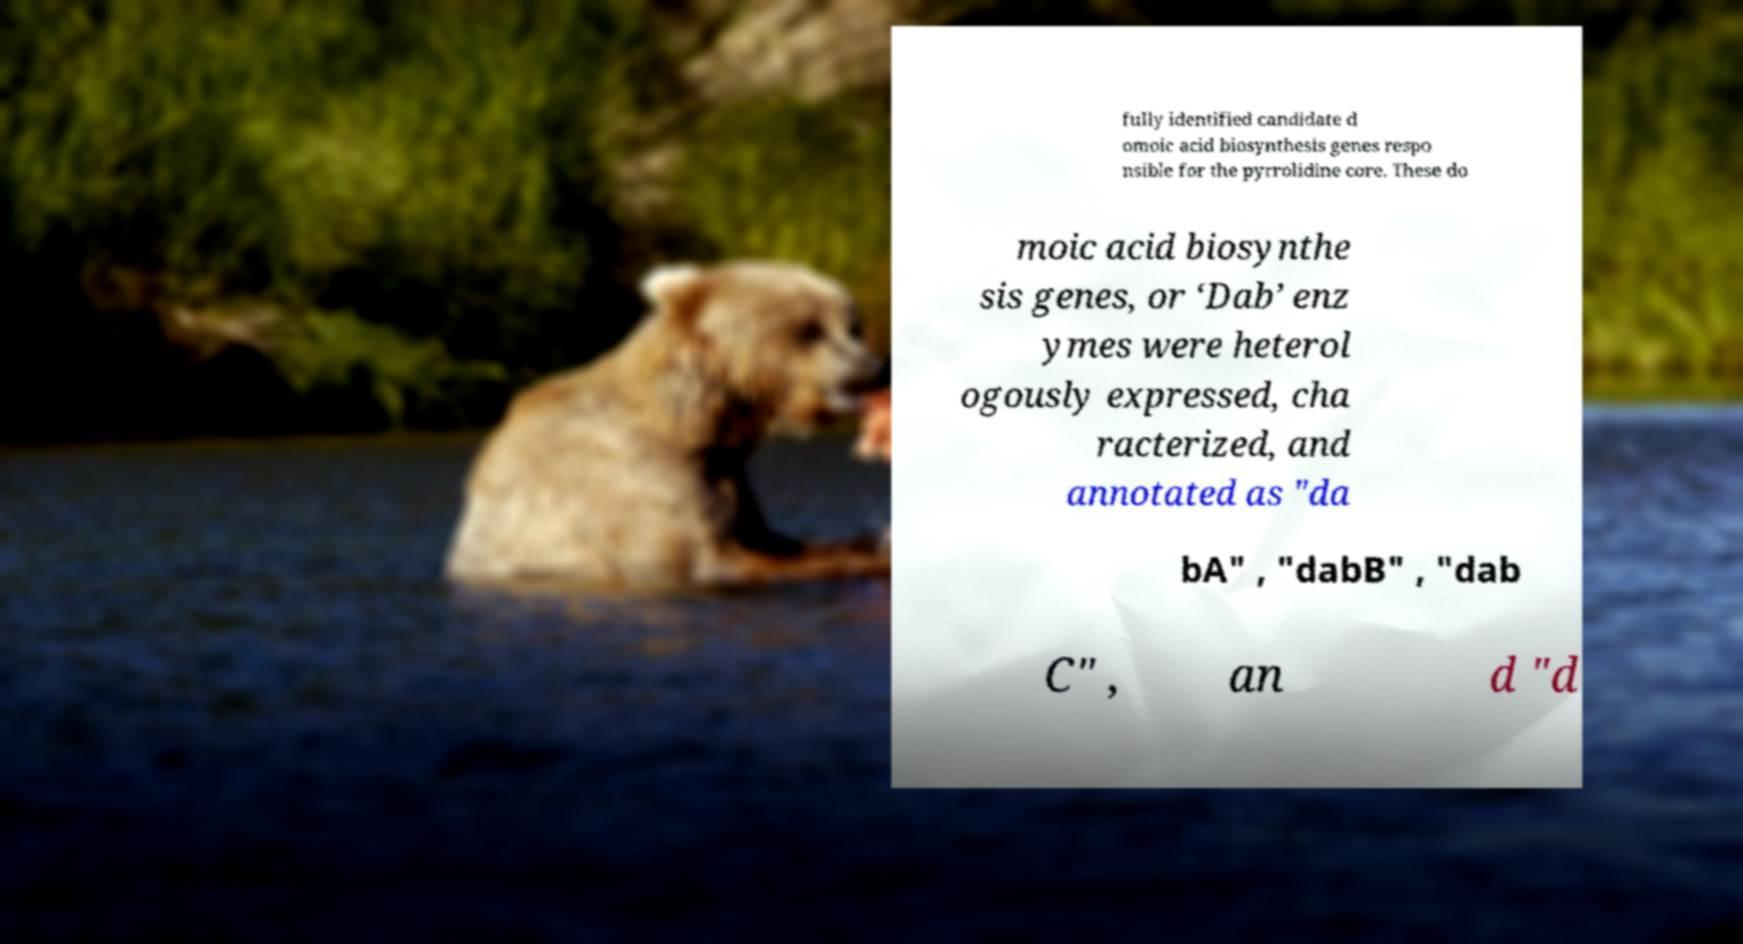For documentation purposes, I need the text within this image transcribed. Could you provide that? fully identified candidate d omoic acid biosynthesis genes respo nsible for the pyrrolidine core. These do moic acid biosynthe sis genes, or ‘Dab’ enz ymes were heterol ogously expressed, cha racterized, and annotated as "da bA" , "dabB" , "dab C" , an d "d 